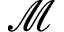<formula> <loc_0><loc_0><loc_500><loc_500>\mathcal { M }</formula> 